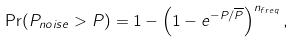Convert formula to latex. <formula><loc_0><loc_0><loc_500><loc_500>\Pr ( P _ { n o i s e } > P ) = 1 - \left ( 1 - e ^ { - P / \overline { P } } \right ) ^ { n _ { f r e q } } ,</formula> 